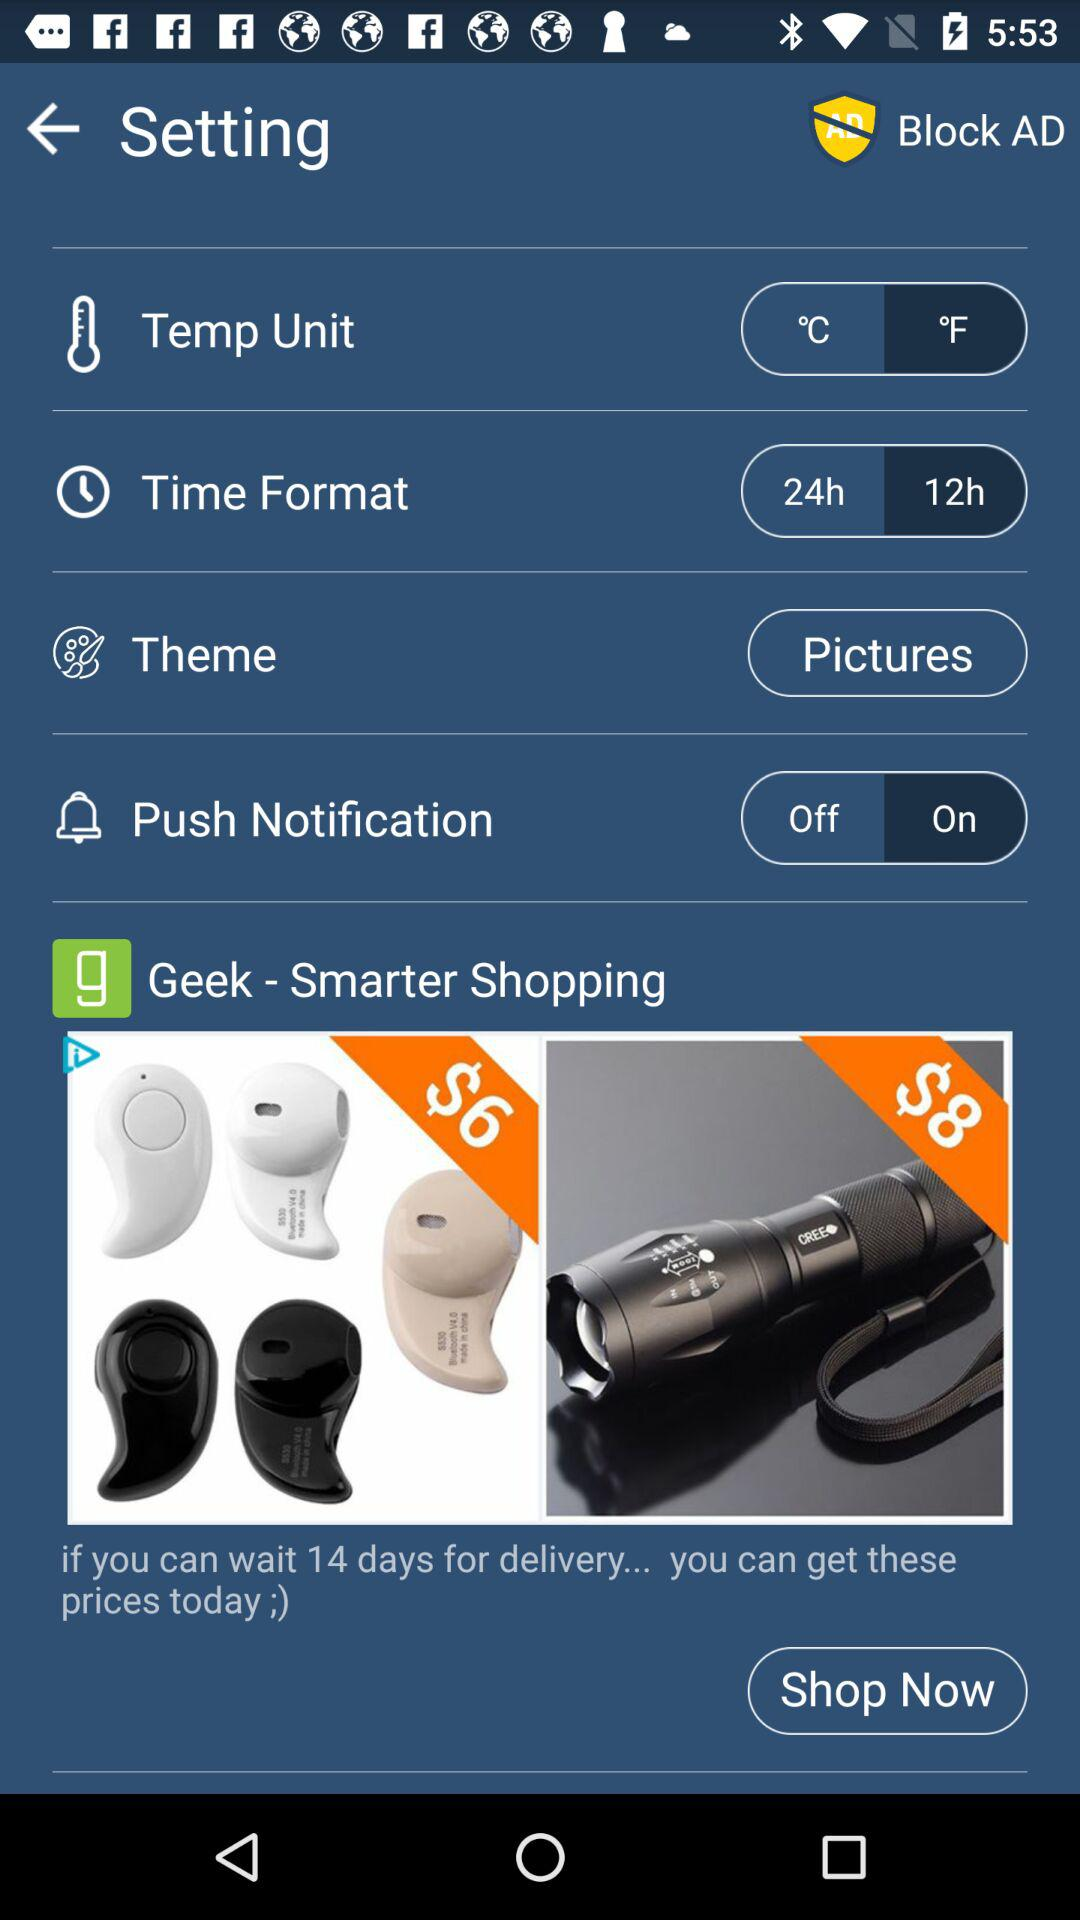What is the selected theme? The selected theme is "Pictures". 